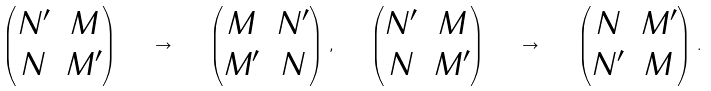<formula> <loc_0><loc_0><loc_500><loc_500>\begin{pmatrix} N ^ { \prime } & M \\ N & M ^ { \prime } \end{pmatrix} \quad \rightarrow \quad \begin{pmatrix} M & N ^ { \prime } \\ M ^ { \prime } & N \end{pmatrix} \, , \quad \begin{pmatrix} N ^ { \prime } & M \\ N & M ^ { \prime } \end{pmatrix} \quad \rightarrow \quad \begin{pmatrix} N & M ^ { \prime } \\ N ^ { \prime } & M \end{pmatrix} \, .</formula> 